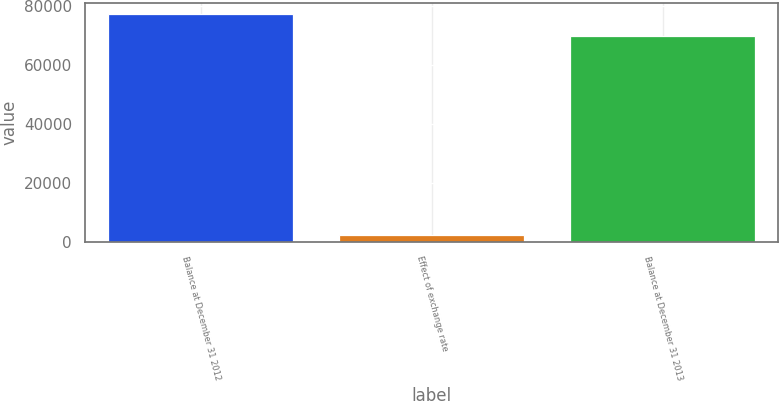Convert chart. <chart><loc_0><loc_0><loc_500><loc_500><bar_chart><fcel>Balance at December 31 2012<fcel>Effect of exchange rate<fcel>Balance at December 31 2013<nl><fcel>77286.5<fcel>2468<fcel>70019<nl></chart> 